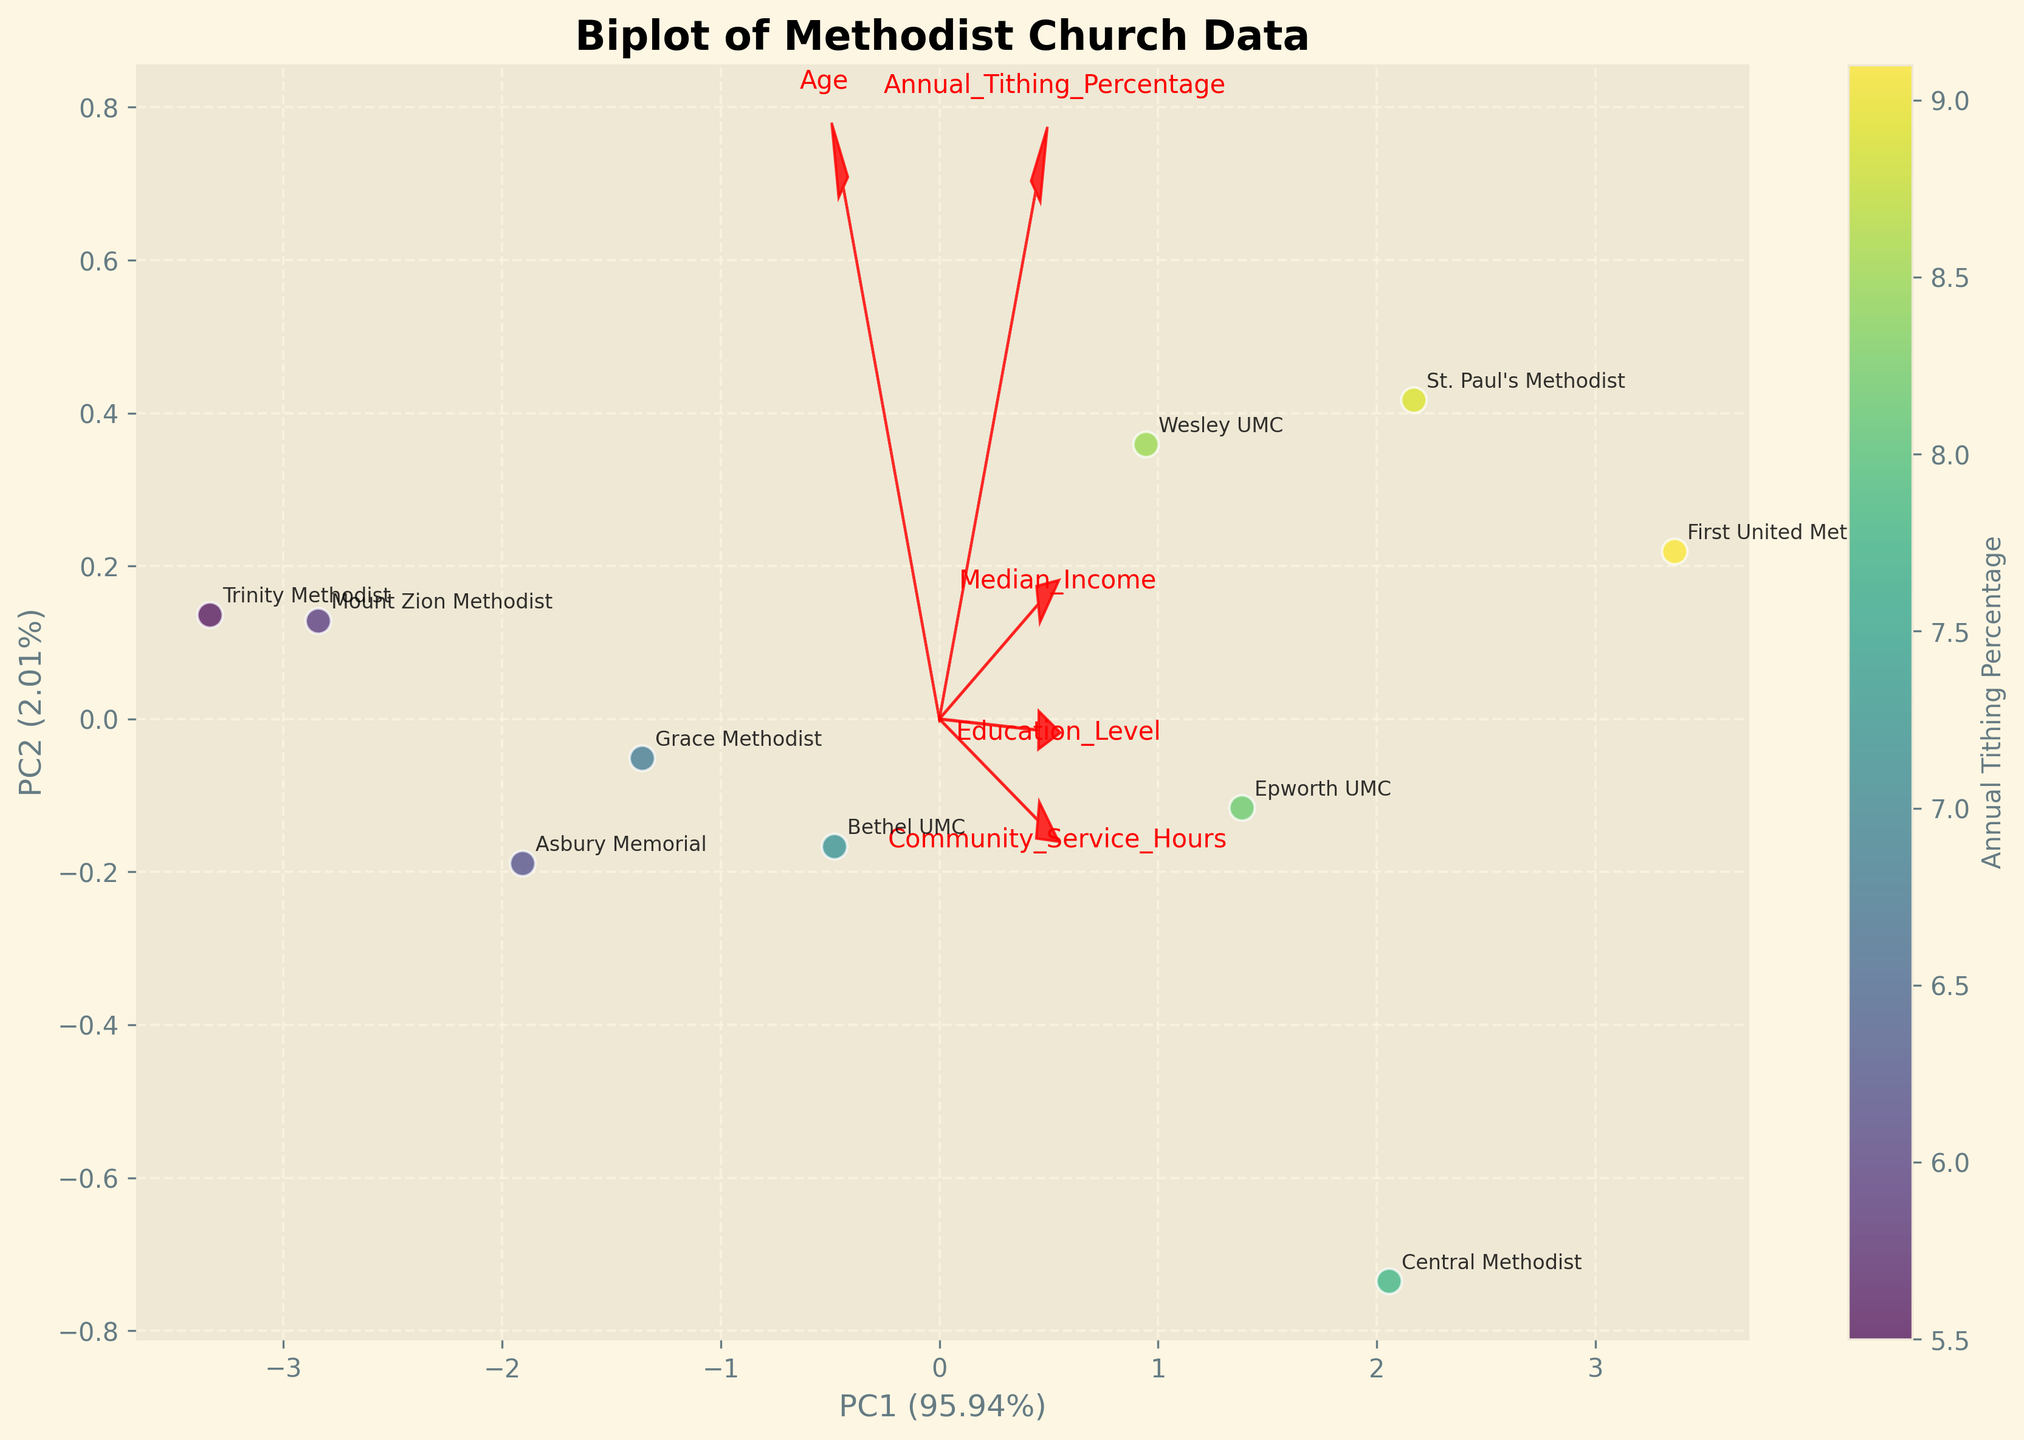what is the title of the plot? The title is written at the top of the chart. It provides a concise description of the data being visualized. Here, it reads 'Biplot of Methodist Church Data'.
Answer: Biplot of Methodist Church Data what are the labels for the x-axis and y-axis? The x-axis and y-axis labels describe the principal components and their explained variance ratios. Here, 'PC1' represents the first principal component and 'PC2' represents the second principal component, both indicated with their associated variance ratios.
Answer: PC1 and PC2 which church has the highest annual tithing percentage? Look for the scatter point with the highest color intensity according to the color bar, which represents annual tithing percentage. The label next to that point will indicate the church name.
Answer: First United Methodist which features have the strongest influence on PC1 and PC2? The arrows representing features (Annual Tithing Percentage, Median Income, Education Level, Age, Community Service Hours) indicate their influence. The longer the arrow and the closer it aligns to PC1 or PC2, the stronger its influence.
Answer: Annual Tithing Percentage, Median Income, Education Level how does Median Income correlate with Annual Tithing Percentage? Check the direction and length of the arrows for these features. If the arrows are in similar directions, this indicates a positive correlation.
Answer: Positively what church appears closest to the average value of all features? This can be identified by finding the data point closest to the origin (0,0) on the plot, which represents the average value of all features in the PCA-transformed space.
Answer: Bethel UMC which church participates the most in community service hours? Locate the point associated with the highest coordinate in the direction of the Community Service Hours arrow. The label next to this point will identify the church.
Answer: First United Methodist which features seem to have an inverse (negative) relationship with Age according to the biplot? Check for arrows pointing in opposite directions to the Age arrow. Features with arrows directly opposite indicate a negative relationship.
Answer: Education Level, Median Income 